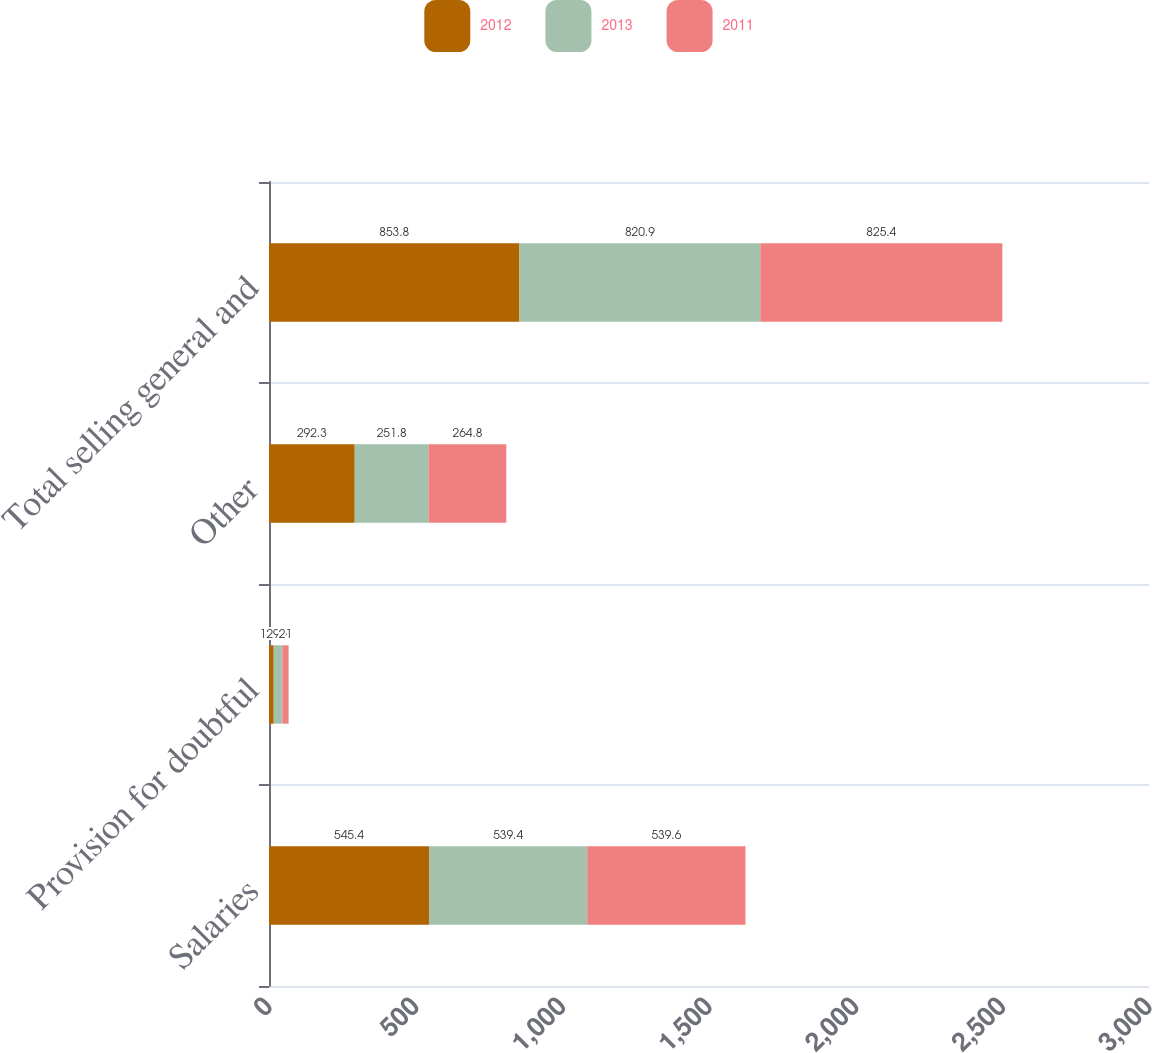<chart> <loc_0><loc_0><loc_500><loc_500><stacked_bar_chart><ecel><fcel>Salaries<fcel>Provision for doubtful<fcel>Other<fcel>Total selling general and<nl><fcel>2012<fcel>545.4<fcel>16.1<fcel>292.3<fcel>853.8<nl><fcel>2013<fcel>539.4<fcel>29.7<fcel>251.8<fcel>820.9<nl><fcel>2011<fcel>539.6<fcel>21<fcel>264.8<fcel>825.4<nl></chart> 